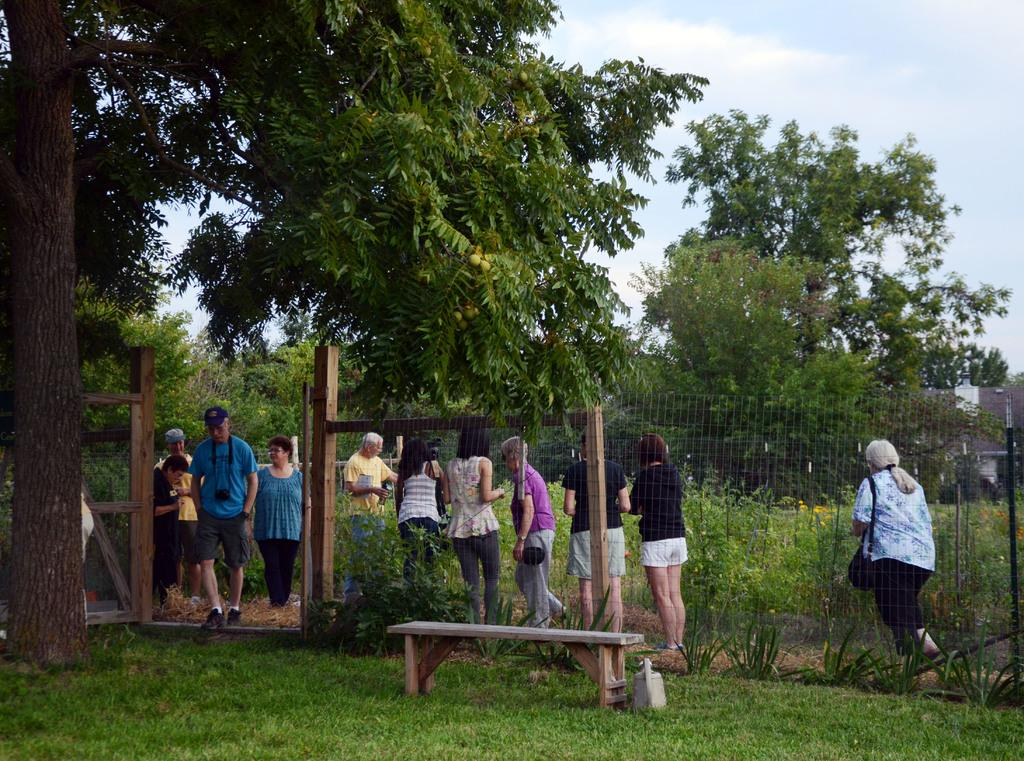How many people are in the image? There is a group of people in the image, but the exact number cannot be determined from the provided facts. What are the people in the image doing? Some people are standing, while others are walking. What type of surface is visible in the image? There is ground in the image. What type of vegetation is present in the image? Trees are present in the image. What type of barrier is visible in the image? There is a fence in the image. What type of seating is present in the image? There is a bench in the image. What is visible in the background of the image? The sky is visible in the background of the image. What can be seen in the sky? Clouds are present in the sky. What type of sign is visible on the bench in the image? There is no sign present on the bench in the image. What type of drink is being consumed by the people in the image? The provided facts do not mention any drinks being consumed by the people in the image. 